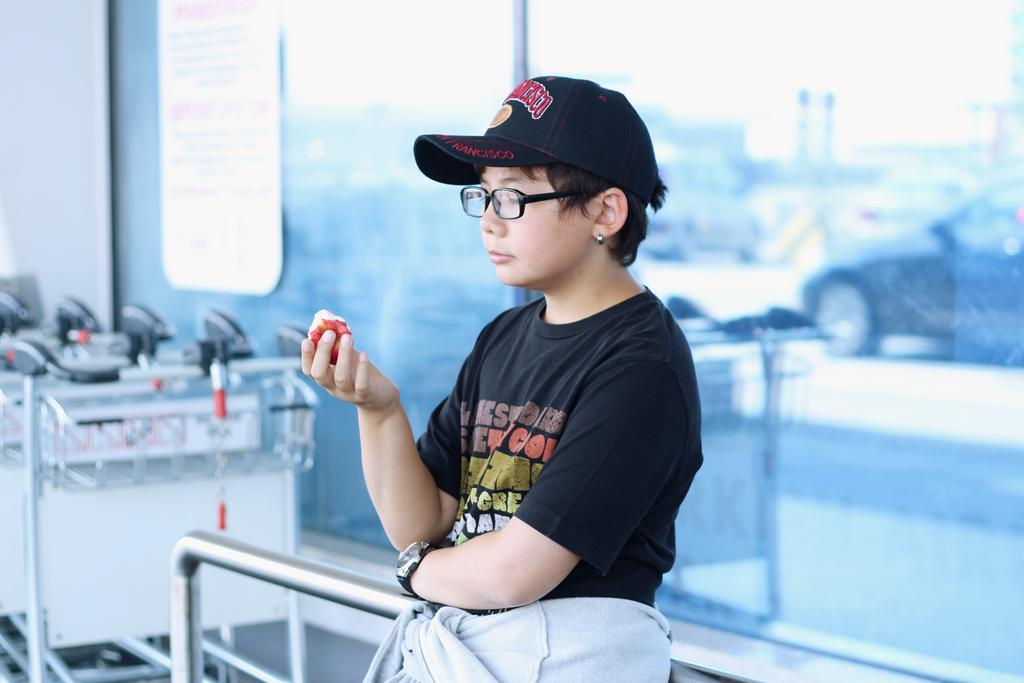What accessory is the person in the image wearing on their face? The person in the image is wearing spectacles. What type of headwear is the person wearing? The person is wearing a cap. What is the person holding in the image? The person is holding food. What can be seen on a glass surface in the image? There is a board on a glass surface. What type of transportation is visible in the image? There is a reflection of a vehicle on the glass surface. What objects are used for carrying items in the image? There are carts in the image. What type of grass is growing on the person's chin in the image? There is no grass growing on the person's chin in the image. 